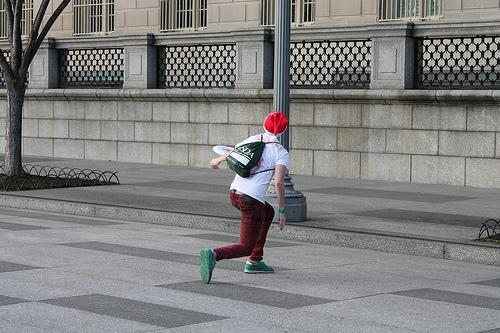Mention any particular accessory or item the person is wearing on their back in the image. The person is wearing a black backpack with white graphics and straps on their back. What is the person in the image wearing on their head? The person is wearing a red Santa hat with a white fuzzy ball on the end. Please detail the type of hat and its colors that the person has on. The person has a red and white Santa hat, featuring a white pom pom on the end. Identify the type of shirt worn by the character in the image and describe the style. The person is wearing a white short sleeve t-shirt, possibly with red lettering or design. In the image, describe the type of vegetation present nearest to the person. There is a tree with no leaves growing in the sidewalk next to brown dirt, surrounded by a semicircular wire fencing. Please describe the footwear worn by the individual in the image. The person is wearing a pair of bright green tennis shoes or sneakers. Please provide a description of a nearby tall object in the image, along with its color and material. A tall grey pole, possibly a lamp post, which could be made of metal or stone, is positioned near the person. Describe the location where the person is standing and provide details about the ground. The person is standing on a stone ground, likely made of gray stone blocks, and part of a sidewalk with a concrete railing. Can you identify the type of pants and color worn by the person in the image? The person is wearing maroon pants, likely jeans, in a dark red shade. What object is the person interacting with in the image, and how are they doing so? The person is interacting with a white frisbee, seemingly attempting to catch it with their hand. 